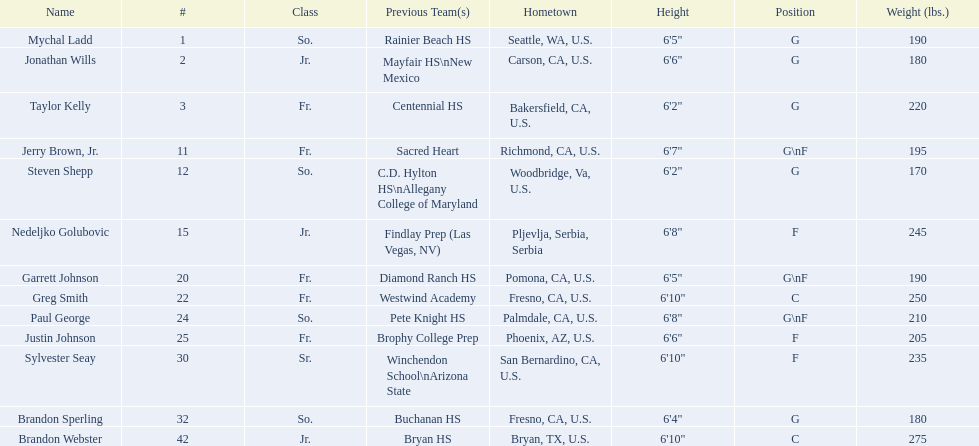How many players and both guard (g) and forward (f)? 3. 